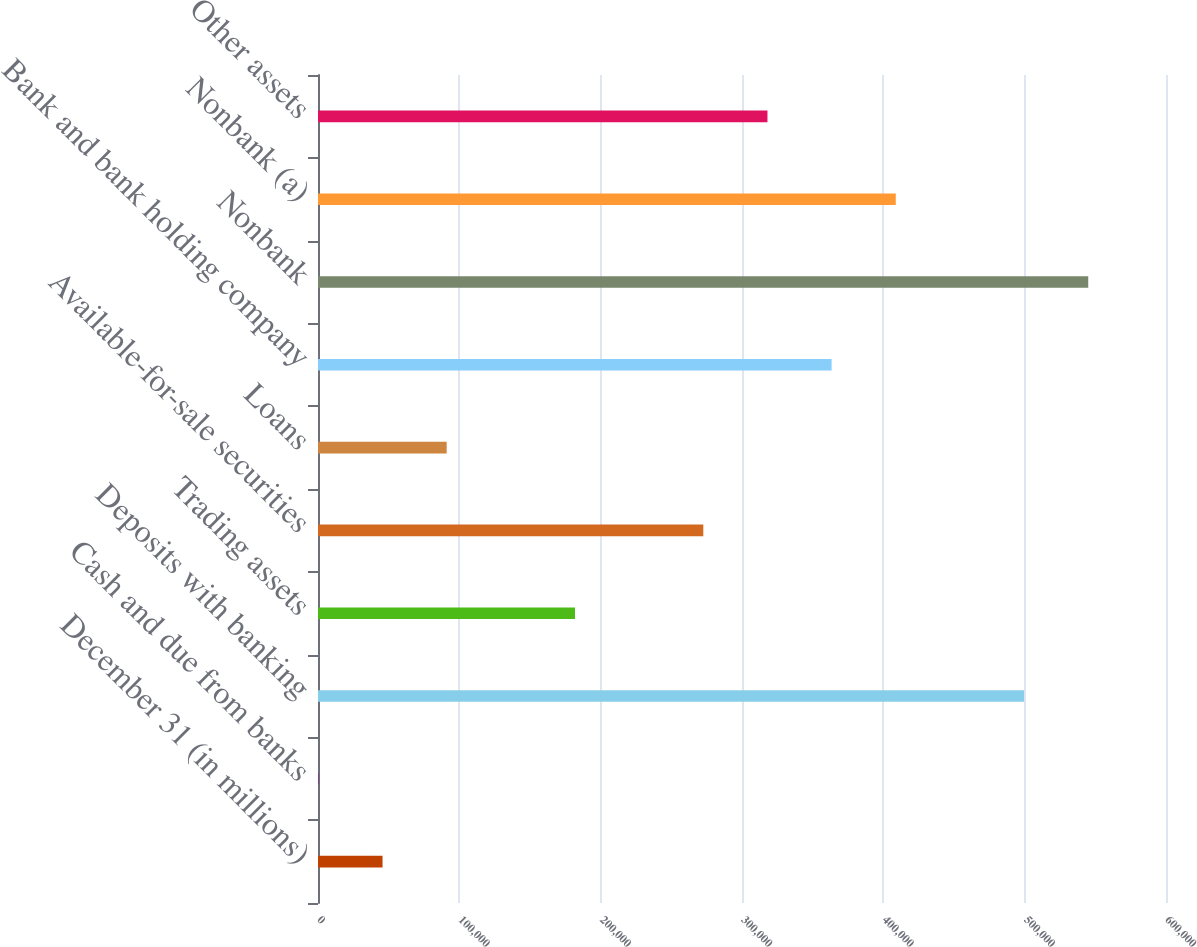Convert chart. <chart><loc_0><loc_0><loc_500><loc_500><bar_chart><fcel>December 31 (in millions)<fcel>Cash and due from banks<fcel>Deposits with banking<fcel>Trading assets<fcel>Available-for-sale securities<fcel>Loans<fcel>Bank and bank holding company<fcel>Nonbank<fcel>Nonbank (a)<fcel>Other assets<nl><fcel>45657.1<fcel>264<fcel>499588<fcel>181836<fcel>272623<fcel>91050.2<fcel>363409<fcel>544981<fcel>408802<fcel>318016<nl></chart> 